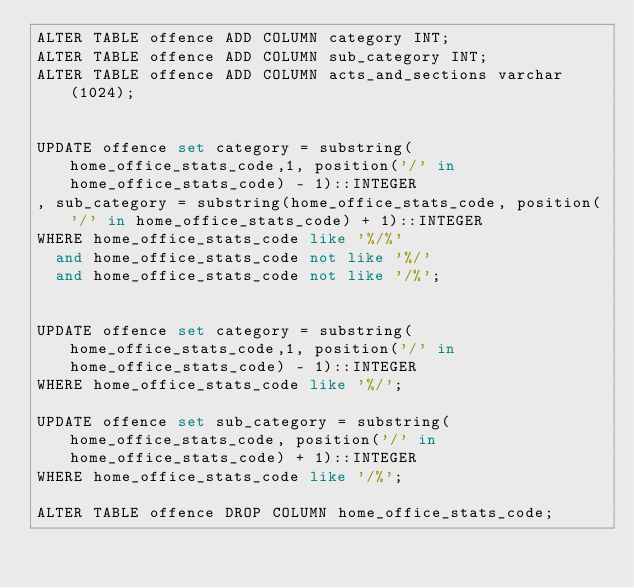<code> <loc_0><loc_0><loc_500><loc_500><_SQL_>ALTER TABLE offence ADD COLUMN category INT;
ALTER TABLE offence ADD COLUMN sub_category INT;
ALTER TABLE offence ADD COLUMN acts_and_sections varchar(1024);


UPDATE offence set category = substring(home_office_stats_code,1, position('/' in home_office_stats_code) - 1)::INTEGER
, sub_category = substring(home_office_stats_code, position('/' in home_office_stats_code) + 1)::INTEGER
WHERE home_office_stats_code like '%/%'
  and home_office_stats_code not like '%/'
  and home_office_stats_code not like '/%';


UPDATE offence set category = substring(home_office_stats_code,1, position('/' in home_office_stats_code) - 1)::INTEGER
WHERE home_office_stats_code like '%/';

UPDATE offence set sub_category = substring(home_office_stats_code, position('/' in home_office_stats_code) + 1)::INTEGER
WHERE home_office_stats_code like '/%';

ALTER TABLE offence DROP COLUMN home_office_stats_code;
</code> 